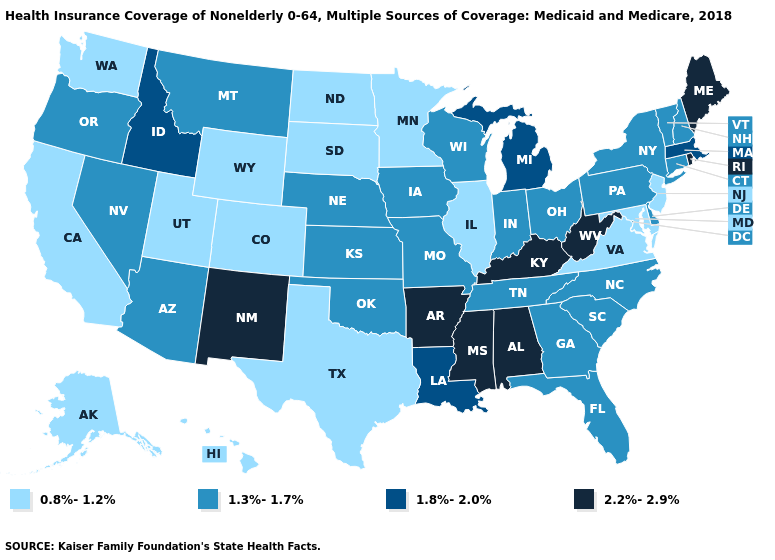What is the lowest value in states that border Tennessee?
Give a very brief answer. 0.8%-1.2%. What is the value of Vermont?
Quick response, please. 1.3%-1.7%. How many symbols are there in the legend?
Give a very brief answer. 4. Name the states that have a value in the range 0.8%-1.2%?
Keep it brief. Alaska, California, Colorado, Hawaii, Illinois, Maryland, Minnesota, New Jersey, North Dakota, South Dakota, Texas, Utah, Virginia, Washington, Wyoming. What is the value of South Carolina?
Short answer required. 1.3%-1.7%. What is the value of Massachusetts?
Write a very short answer. 1.8%-2.0%. Which states have the highest value in the USA?
Short answer required. Alabama, Arkansas, Kentucky, Maine, Mississippi, New Mexico, Rhode Island, West Virginia. Does North Carolina have a higher value than Indiana?
Short answer required. No. Name the states that have a value in the range 1.3%-1.7%?
Keep it brief. Arizona, Connecticut, Delaware, Florida, Georgia, Indiana, Iowa, Kansas, Missouri, Montana, Nebraska, Nevada, New Hampshire, New York, North Carolina, Ohio, Oklahoma, Oregon, Pennsylvania, South Carolina, Tennessee, Vermont, Wisconsin. Name the states that have a value in the range 1.8%-2.0%?
Keep it brief. Idaho, Louisiana, Massachusetts, Michigan. Name the states that have a value in the range 1.8%-2.0%?
Keep it brief. Idaho, Louisiana, Massachusetts, Michigan. Name the states that have a value in the range 1.8%-2.0%?
Write a very short answer. Idaho, Louisiana, Massachusetts, Michigan. Which states hav the highest value in the West?
Quick response, please. New Mexico. Name the states that have a value in the range 2.2%-2.9%?
Concise answer only. Alabama, Arkansas, Kentucky, Maine, Mississippi, New Mexico, Rhode Island, West Virginia. What is the value of New York?
Answer briefly. 1.3%-1.7%. 